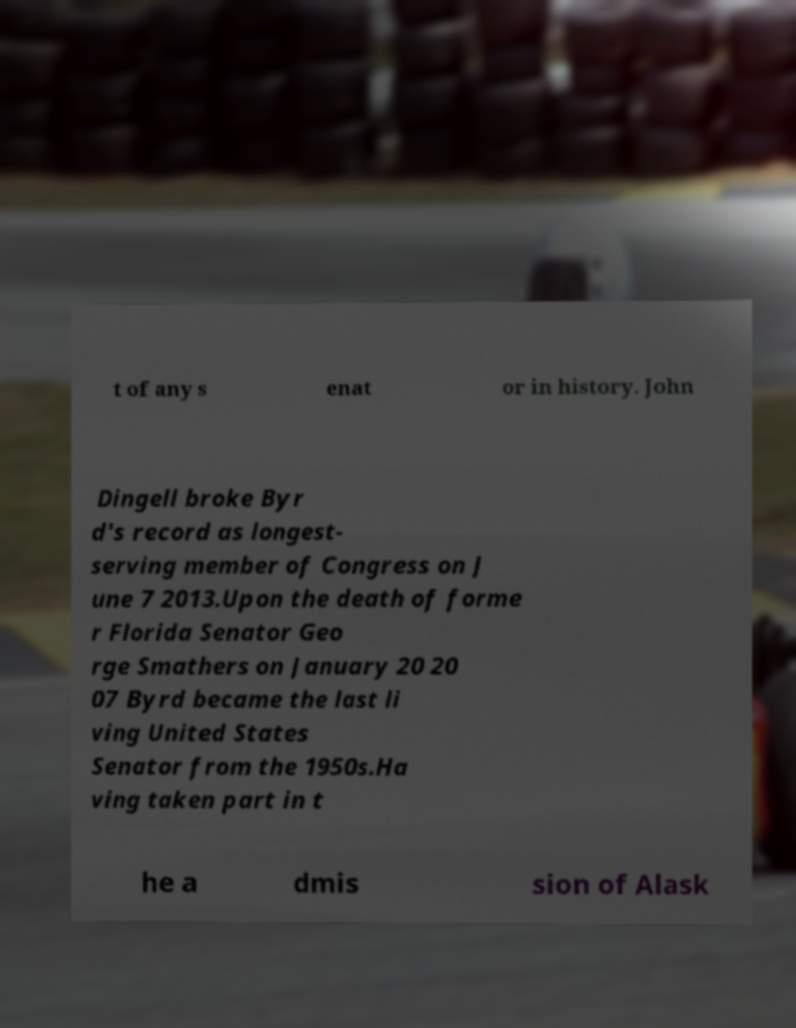I need the written content from this picture converted into text. Can you do that? t of any s enat or in history. John Dingell broke Byr d's record as longest- serving member of Congress on J une 7 2013.Upon the death of forme r Florida Senator Geo rge Smathers on January 20 20 07 Byrd became the last li ving United States Senator from the 1950s.Ha ving taken part in t he a dmis sion of Alask 